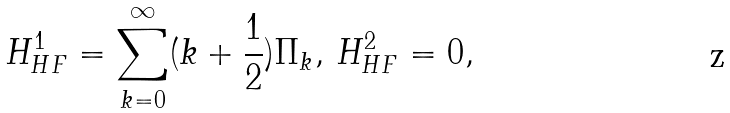<formula> <loc_0><loc_0><loc_500><loc_500>H _ { H F } ^ { 1 } = \sum _ { k = 0 } ^ { \infty } ( k + \frac { 1 } { 2 } ) \Pi _ { k } , \, H _ { H F } ^ { 2 } = 0 ,</formula> 